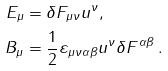Convert formula to latex. <formula><loc_0><loc_0><loc_500><loc_500>E _ { \mu } & = \delta F _ { \mu \nu } u ^ { \nu } , \\ B _ { \mu } & = \frac { 1 } { 2 } \varepsilon _ { \mu \nu \alpha \beta } u ^ { \nu } \delta F ^ { \alpha \beta } \, .</formula> 